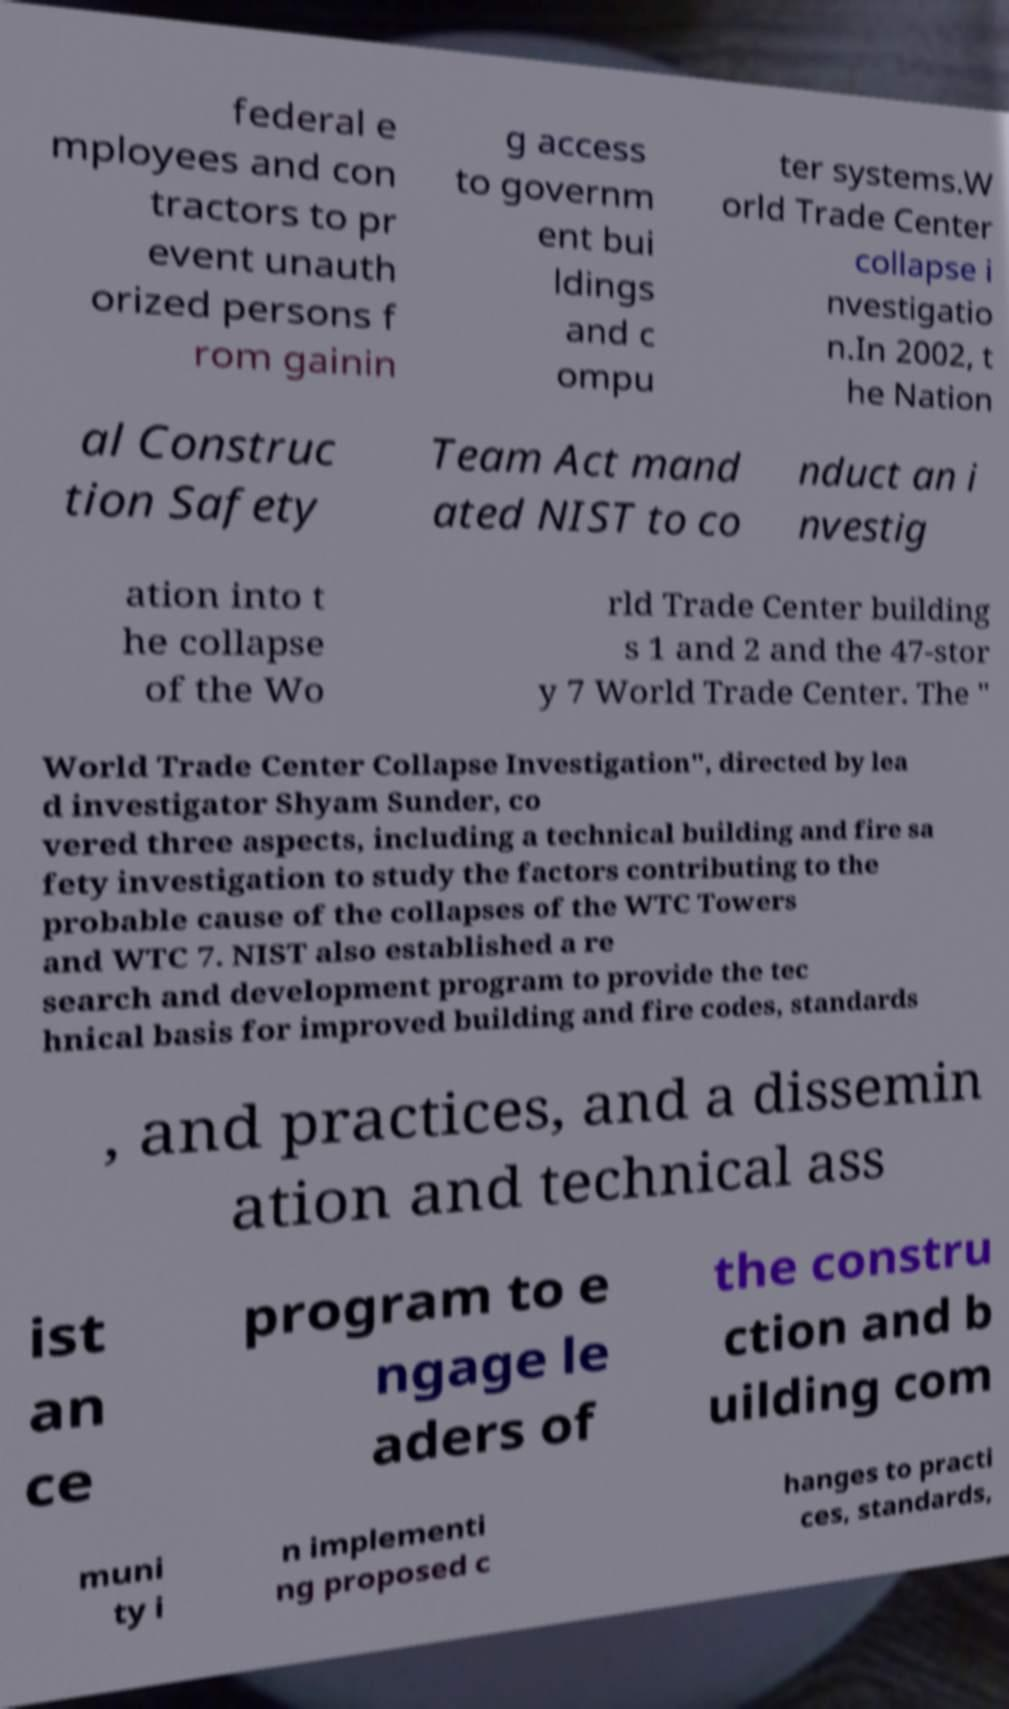Can you accurately transcribe the text from the provided image for me? federal e mployees and con tractors to pr event unauth orized persons f rom gainin g access to governm ent bui ldings and c ompu ter systems.W orld Trade Center collapse i nvestigatio n.In 2002, t he Nation al Construc tion Safety Team Act mand ated NIST to co nduct an i nvestig ation into t he collapse of the Wo rld Trade Center building s 1 and 2 and the 47-stor y 7 World Trade Center. The " World Trade Center Collapse Investigation", directed by lea d investigator Shyam Sunder, co vered three aspects, including a technical building and fire sa fety investigation to study the factors contributing to the probable cause of the collapses of the WTC Towers and WTC 7. NIST also established a re search and development program to provide the tec hnical basis for improved building and fire codes, standards , and practices, and a dissemin ation and technical ass ist an ce program to e ngage le aders of the constru ction and b uilding com muni ty i n implementi ng proposed c hanges to practi ces, standards, 